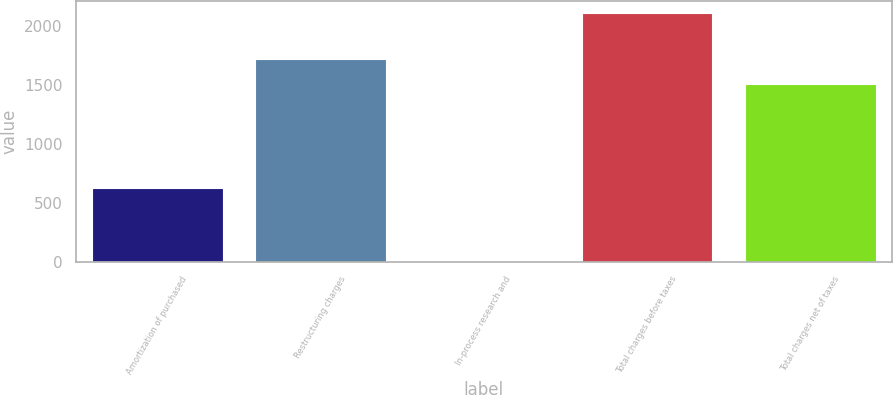Convert chart to OTSL. <chart><loc_0><loc_0><loc_500><loc_500><bar_chart><fcel>Amortization of purchased<fcel>Restructuring charges<fcel>In-process research and<fcel>Total charges before taxes<fcel>Total charges net of taxes<nl><fcel>622<fcel>1719.7<fcel>2<fcel>2109<fcel>1509<nl></chart> 